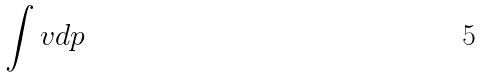Convert formula to latex. <formula><loc_0><loc_0><loc_500><loc_500>\int v d p</formula> 